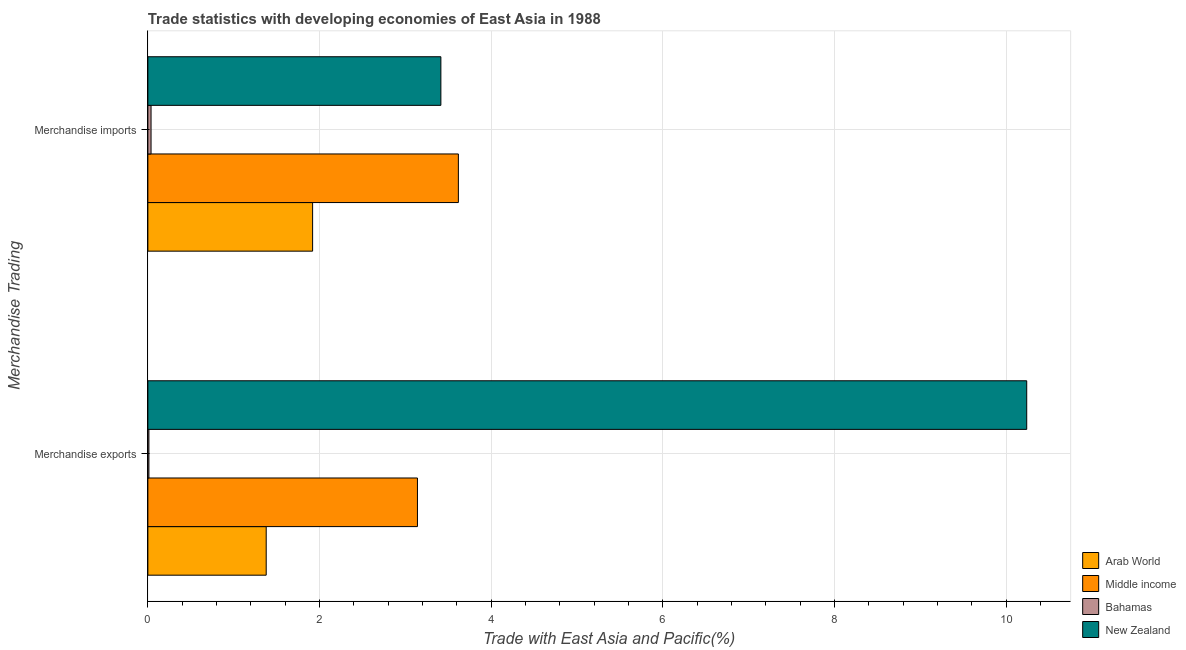How many different coloured bars are there?
Give a very brief answer. 4. How many groups of bars are there?
Ensure brevity in your answer.  2. Are the number of bars per tick equal to the number of legend labels?
Provide a succinct answer. Yes. Are the number of bars on each tick of the Y-axis equal?
Provide a short and direct response. Yes. How many bars are there on the 1st tick from the top?
Offer a very short reply. 4. How many bars are there on the 2nd tick from the bottom?
Your answer should be very brief. 4. What is the label of the 2nd group of bars from the top?
Offer a very short reply. Merchandise exports. What is the merchandise exports in Bahamas?
Give a very brief answer. 0.01. Across all countries, what is the maximum merchandise imports?
Make the answer very short. 3.62. Across all countries, what is the minimum merchandise imports?
Your answer should be compact. 0.04. In which country was the merchandise exports maximum?
Keep it short and to the point. New Zealand. In which country was the merchandise imports minimum?
Ensure brevity in your answer.  Bahamas. What is the total merchandise imports in the graph?
Give a very brief answer. 8.99. What is the difference between the merchandise imports in Bahamas and that in Arab World?
Provide a short and direct response. -1.88. What is the difference between the merchandise imports in Middle income and the merchandise exports in Bahamas?
Your response must be concise. 3.61. What is the average merchandise imports per country?
Your response must be concise. 2.25. What is the difference between the merchandise exports and merchandise imports in New Zealand?
Provide a short and direct response. 6.82. In how many countries, is the merchandise exports greater than 3.6 %?
Offer a terse response. 1. What is the ratio of the merchandise imports in Bahamas to that in Middle income?
Keep it short and to the point. 0.01. Is the merchandise exports in Bahamas less than that in New Zealand?
Your response must be concise. Yes. What does the 4th bar from the top in Merchandise imports represents?
Offer a terse response. Arab World. What does the 4th bar from the bottom in Merchandise exports represents?
Provide a short and direct response. New Zealand. Are all the bars in the graph horizontal?
Provide a succinct answer. Yes. What is the difference between two consecutive major ticks on the X-axis?
Offer a terse response. 2. Are the values on the major ticks of X-axis written in scientific E-notation?
Keep it short and to the point. No. Does the graph contain any zero values?
Your response must be concise. No. Does the graph contain grids?
Your response must be concise. Yes. Where does the legend appear in the graph?
Offer a terse response. Bottom right. What is the title of the graph?
Ensure brevity in your answer.  Trade statistics with developing economies of East Asia in 1988. Does "Eritrea" appear as one of the legend labels in the graph?
Ensure brevity in your answer.  No. What is the label or title of the X-axis?
Provide a succinct answer. Trade with East Asia and Pacific(%). What is the label or title of the Y-axis?
Your response must be concise. Merchandise Trading. What is the Trade with East Asia and Pacific(%) of Arab World in Merchandise exports?
Provide a succinct answer. 1.38. What is the Trade with East Asia and Pacific(%) of Middle income in Merchandise exports?
Keep it short and to the point. 3.14. What is the Trade with East Asia and Pacific(%) in Bahamas in Merchandise exports?
Your response must be concise. 0.01. What is the Trade with East Asia and Pacific(%) in New Zealand in Merchandise exports?
Ensure brevity in your answer.  10.24. What is the Trade with East Asia and Pacific(%) in Arab World in Merchandise imports?
Give a very brief answer. 1.92. What is the Trade with East Asia and Pacific(%) of Middle income in Merchandise imports?
Your response must be concise. 3.62. What is the Trade with East Asia and Pacific(%) in Bahamas in Merchandise imports?
Provide a short and direct response. 0.04. What is the Trade with East Asia and Pacific(%) in New Zealand in Merchandise imports?
Your answer should be very brief. 3.41. Across all Merchandise Trading, what is the maximum Trade with East Asia and Pacific(%) in Arab World?
Give a very brief answer. 1.92. Across all Merchandise Trading, what is the maximum Trade with East Asia and Pacific(%) of Middle income?
Your response must be concise. 3.62. Across all Merchandise Trading, what is the maximum Trade with East Asia and Pacific(%) of Bahamas?
Your response must be concise. 0.04. Across all Merchandise Trading, what is the maximum Trade with East Asia and Pacific(%) of New Zealand?
Your answer should be very brief. 10.24. Across all Merchandise Trading, what is the minimum Trade with East Asia and Pacific(%) in Arab World?
Offer a very short reply. 1.38. Across all Merchandise Trading, what is the minimum Trade with East Asia and Pacific(%) of Middle income?
Make the answer very short. 3.14. Across all Merchandise Trading, what is the minimum Trade with East Asia and Pacific(%) of Bahamas?
Provide a succinct answer. 0.01. Across all Merchandise Trading, what is the minimum Trade with East Asia and Pacific(%) in New Zealand?
Provide a succinct answer. 3.41. What is the total Trade with East Asia and Pacific(%) in Arab World in the graph?
Offer a very short reply. 3.3. What is the total Trade with East Asia and Pacific(%) in Middle income in the graph?
Your answer should be very brief. 6.76. What is the total Trade with East Asia and Pacific(%) of Bahamas in the graph?
Ensure brevity in your answer.  0.05. What is the total Trade with East Asia and Pacific(%) of New Zealand in the graph?
Provide a succinct answer. 13.65. What is the difference between the Trade with East Asia and Pacific(%) of Arab World in Merchandise exports and that in Merchandise imports?
Your answer should be very brief. -0.54. What is the difference between the Trade with East Asia and Pacific(%) in Middle income in Merchandise exports and that in Merchandise imports?
Provide a succinct answer. -0.48. What is the difference between the Trade with East Asia and Pacific(%) of Bahamas in Merchandise exports and that in Merchandise imports?
Offer a terse response. -0.03. What is the difference between the Trade with East Asia and Pacific(%) in New Zealand in Merchandise exports and that in Merchandise imports?
Your answer should be very brief. 6.82. What is the difference between the Trade with East Asia and Pacific(%) of Arab World in Merchandise exports and the Trade with East Asia and Pacific(%) of Middle income in Merchandise imports?
Give a very brief answer. -2.24. What is the difference between the Trade with East Asia and Pacific(%) of Arab World in Merchandise exports and the Trade with East Asia and Pacific(%) of Bahamas in Merchandise imports?
Offer a very short reply. 1.34. What is the difference between the Trade with East Asia and Pacific(%) in Arab World in Merchandise exports and the Trade with East Asia and Pacific(%) in New Zealand in Merchandise imports?
Give a very brief answer. -2.03. What is the difference between the Trade with East Asia and Pacific(%) in Middle income in Merchandise exports and the Trade with East Asia and Pacific(%) in Bahamas in Merchandise imports?
Your response must be concise. 3.1. What is the difference between the Trade with East Asia and Pacific(%) of Middle income in Merchandise exports and the Trade with East Asia and Pacific(%) of New Zealand in Merchandise imports?
Your response must be concise. -0.27. What is the difference between the Trade with East Asia and Pacific(%) in Bahamas in Merchandise exports and the Trade with East Asia and Pacific(%) in New Zealand in Merchandise imports?
Offer a terse response. -3.4. What is the average Trade with East Asia and Pacific(%) in Arab World per Merchandise Trading?
Your response must be concise. 1.65. What is the average Trade with East Asia and Pacific(%) of Middle income per Merchandise Trading?
Your answer should be compact. 3.38. What is the average Trade with East Asia and Pacific(%) in Bahamas per Merchandise Trading?
Give a very brief answer. 0.02. What is the average Trade with East Asia and Pacific(%) of New Zealand per Merchandise Trading?
Offer a very short reply. 6.83. What is the difference between the Trade with East Asia and Pacific(%) of Arab World and Trade with East Asia and Pacific(%) of Middle income in Merchandise exports?
Ensure brevity in your answer.  -1.76. What is the difference between the Trade with East Asia and Pacific(%) of Arab World and Trade with East Asia and Pacific(%) of Bahamas in Merchandise exports?
Make the answer very short. 1.37. What is the difference between the Trade with East Asia and Pacific(%) of Arab World and Trade with East Asia and Pacific(%) of New Zealand in Merchandise exports?
Your response must be concise. -8.86. What is the difference between the Trade with East Asia and Pacific(%) of Middle income and Trade with East Asia and Pacific(%) of Bahamas in Merchandise exports?
Ensure brevity in your answer.  3.13. What is the difference between the Trade with East Asia and Pacific(%) in Middle income and Trade with East Asia and Pacific(%) in New Zealand in Merchandise exports?
Your answer should be very brief. -7.1. What is the difference between the Trade with East Asia and Pacific(%) in Bahamas and Trade with East Asia and Pacific(%) in New Zealand in Merchandise exports?
Your answer should be very brief. -10.23. What is the difference between the Trade with East Asia and Pacific(%) in Arab World and Trade with East Asia and Pacific(%) in Middle income in Merchandise imports?
Keep it short and to the point. -1.7. What is the difference between the Trade with East Asia and Pacific(%) in Arab World and Trade with East Asia and Pacific(%) in Bahamas in Merchandise imports?
Ensure brevity in your answer.  1.88. What is the difference between the Trade with East Asia and Pacific(%) of Arab World and Trade with East Asia and Pacific(%) of New Zealand in Merchandise imports?
Provide a short and direct response. -1.49. What is the difference between the Trade with East Asia and Pacific(%) in Middle income and Trade with East Asia and Pacific(%) in Bahamas in Merchandise imports?
Give a very brief answer. 3.58. What is the difference between the Trade with East Asia and Pacific(%) in Middle income and Trade with East Asia and Pacific(%) in New Zealand in Merchandise imports?
Ensure brevity in your answer.  0.2. What is the difference between the Trade with East Asia and Pacific(%) in Bahamas and Trade with East Asia and Pacific(%) in New Zealand in Merchandise imports?
Your answer should be compact. -3.38. What is the ratio of the Trade with East Asia and Pacific(%) in Arab World in Merchandise exports to that in Merchandise imports?
Make the answer very short. 0.72. What is the ratio of the Trade with East Asia and Pacific(%) of Middle income in Merchandise exports to that in Merchandise imports?
Keep it short and to the point. 0.87. What is the ratio of the Trade with East Asia and Pacific(%) in Bahamas in Merchandise exports to that in Merchandise imports?
Make the answer very short. 0.33. What is the ratio of the Trade with East Asia and Pacific(%) of New Zealand in Merchandise exports to that in Merchandise imports?
Your answer should be very brief. 3. What is the difference between the highest and the second highest Trade with East Asia and Pacific(%) of Arab World?
Your response must be concise. 0.54. What is the difference between the highest and the second highest Trade with East Asia and Pacific(%) of Middle income?
Offer a terse response. 0.48. What is the difference between the highest and the second highest Trade with East Asia and Pacific(%) in Bahamas?
Offer a very short reply. 0.03. What is the difference between the highest and the second highest Trade with East Asia and Pacific(%) in New Zealand?
Offer a very short reply. 6.82. What is the difference between the highest and the lowest Trade with East Asia and Pacific(%) of Arab World?
Give a very brief answer. 0.54. What is the difference between the highest and the lowest Trade with East Asia and Pacific(%) in Middle income?
Offer a very short reply. 0.48. What is the difference between the highest and the lowest Trade with East Asia and Pacific(%) in Bahamas?
Keep it short and to the point. 0.03. What is the difference between the highest and the lowest Trade with East Asia and Pacific(%) in New Zealand?
Offer a terse response. 6.82. 